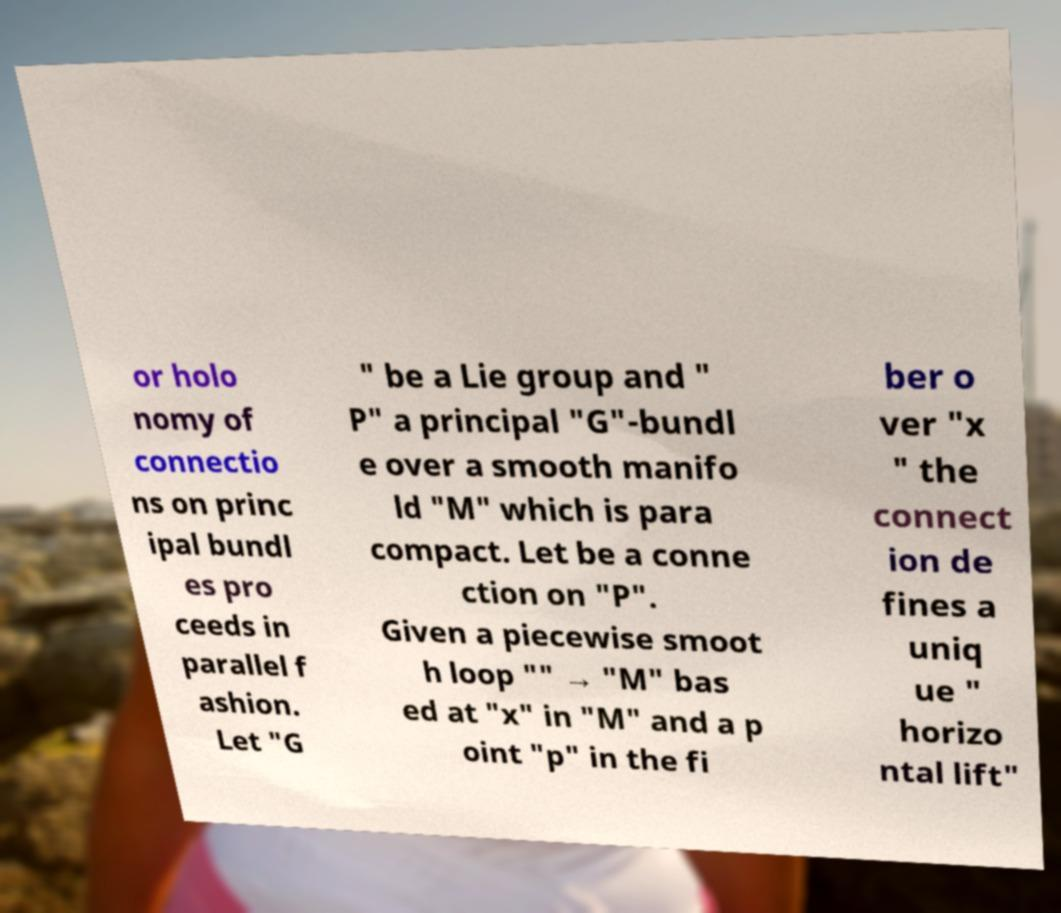Please read and relay the text visible in this image. What does it say? or holo nomy of connectio ns on princ ipal bundl es pro ceeds in parallel f ashion. Let "G " be a Lie group and " P" a principal "G"-bundl e over a smooth manifo ld "M" which is para compact. Let be a conne ction on "P". Given a piecewise smoot h loop "" → "M" bas ed at "x" in "M" and a p oint "p" in the fi ber o ver "x " the connect ion de fines a uniq ue " horizo ntal lift" 